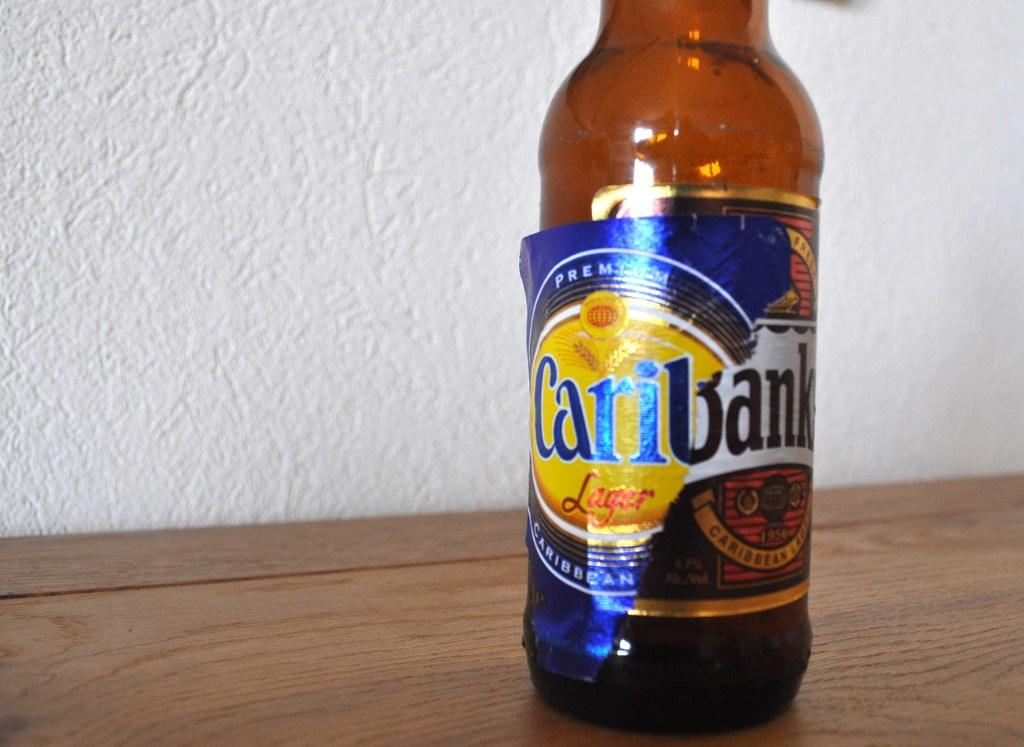<image>
Write a terse but informative summary of the picture. Bottle of Caribank Lager with a blue label on a wooden surface. 